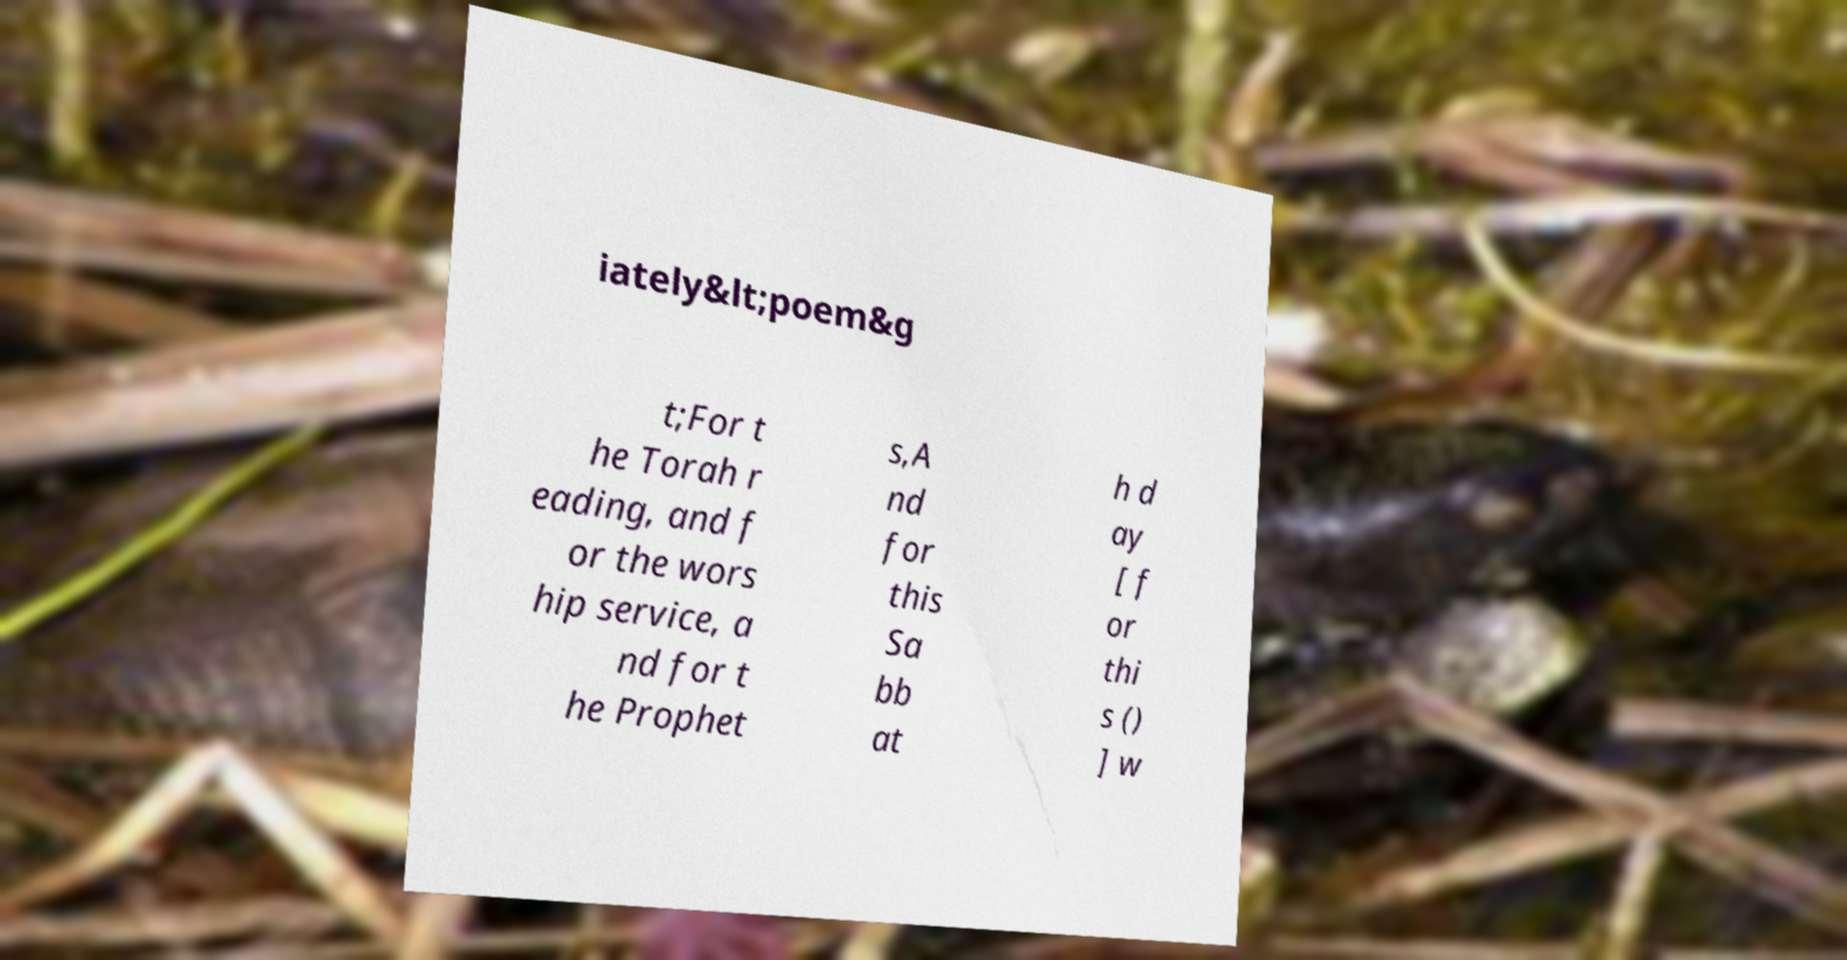There's text embedded in this image that I need extracted. Can you transcribe it verbatim? iately&lt;poem&g t;For t he Torah r eading, and f or the wors hip service, a nd for t he Prophet s,A nd for this Sa bb at h d ay [ f or thi s () ] w 